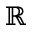Convert formula to latex. <formula><loc_0><loc_0><loc_500><loc_500>\mathbb { R }</formula> 